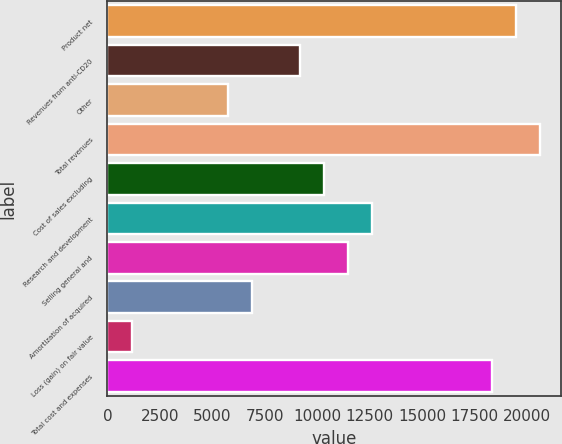Convert chart. <chart><loc_0><loc_0><loc_500><loc_500><bar_chart><fcel>Product net<fcel>Revenues from anti-CD20<fcel>Other<fcel>Total revenues<fcel>Cost of sales excluding<fcel>Research and development<fcel>Selling general and<fcel>Amortization of acquired<fcel>Loss (gain) on fair value<fcel>Total cost and expenses<nl><fcel>19458<fcel>9160.46<fcel>5727.95<fcel>20602.2<fcel>10304.6<fcel>12593<fcel>11448.8<fcel>6872.12<fcel>1151.27<fcel>18313.8<nl></chart> 